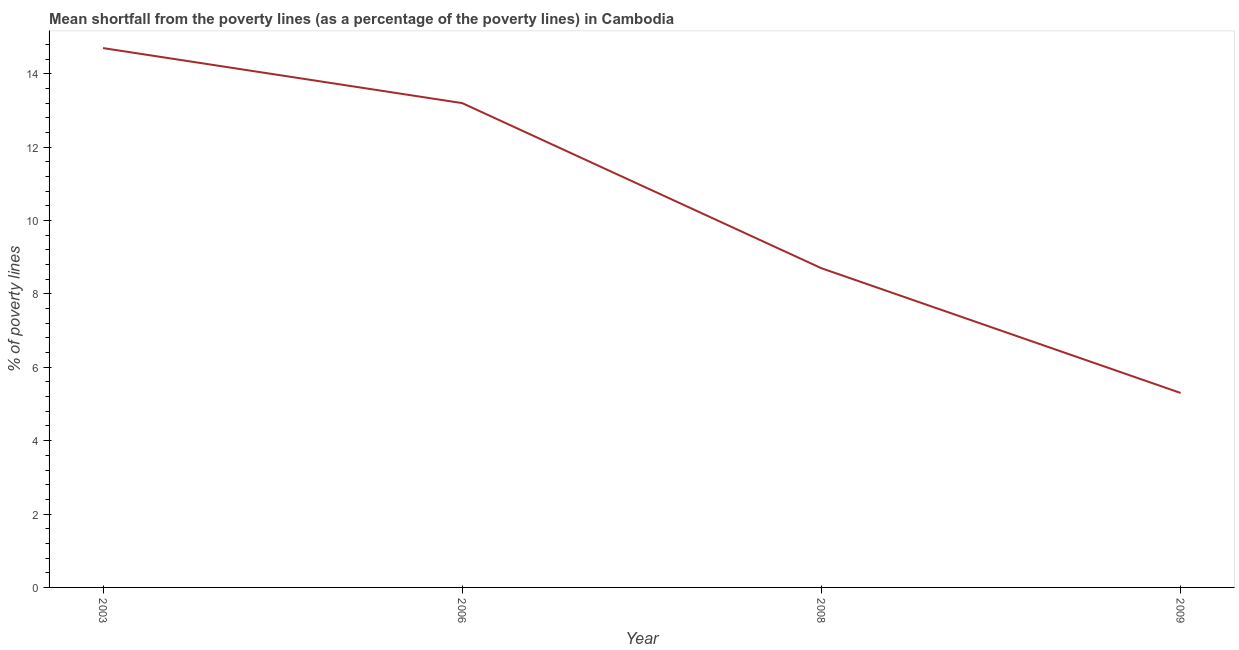Across all years, what is the maximum poverty gap at national poverty lines?
Offer a very short reply. 14.7. Across all years, what is the minimum poverty gap at national poverty lines?
Offer a terse response. 5.3. In which year was the poverty gap at national poverty lines maximum?
Make the answer very short. 2003. What is the sum of the poverty gap at national poverty lines?
Offer a terse response. 41.9. What is the average poverty gap at national poverty lines per year?
Offer a very short reply. 10.47. What is the median poverty gap at national poverty lines?
Keep it short and to the point. 10.95. In how many years, is the poverty gap at national poverty lines greater than 5.6 %?
Provide a short and direct response. 3. What is the ratio of the poverty gap at national poverty lines in 2006 to that in 2008?
Keep it short and to the point. 1.52. Is the poverty gap at national poverty lines in 2003 less than that in 2009?
Your answer should be very brief. No. Is the difference between the poverty gap at national poverty lines in 2006 and 2008 greater than the difference between any two years?
Your response must be concise. No. What is the difference between the highest and the second highest poverty gap at national poverty lines?
Your answer should be very brief. 1.5. What is the difference between the highest and the lowest poverty gap at national poverty lines?
Your answer should be compact. 9.4. In how many years, is the poverty gap at national poverty lines greater than the average poverty gap at national poverty lines taken over all years?
Offer a terse response. 2. Does the poverty gap at national poverty lines monotonically increase over the years?
Provide a succinct answer. No. What is the difference between two consecutive major ticks on the Y-axis?
Keep it short and to the point. 2. Are the values on the major ticks of Y-axis written in scientific E-notation?
Keep it short and to the point. No. Does the graph contain any zero values?
Offer a terse response. No. Does the graph contain grids?
Provide a short and direct response. No. What is the title of the graph?
Your answer should be very brief. Mean shortfall from the poverty lines (as a percentage of the poverty lines) in Cambodia. What is the label or title of the Y-axis?
Ensure brevity in your answer.  % of poverty lines. What is the % of poverty lines in 2003?
Offer a terse response. 14.7. What is the % of poverty lines of 2009?
Make the answer very short. 5.3. What is the difference between the % of poverty lines in 2003 and 2009?
Keep it short and to the point. 9.4. What is the difference between the % of poverty lines in 2006 and 2008?
Make the answer very short. 4.5. What is the difference between the % of poverty lines in 2008 and 2009?
Make the answer very short. 3.4. What is the ratio of the % of poverty lines in 2003 to that in 2006?
Your response must be concise. 1.11. What is the ratio of the % of poverty lines in 2003 to that in 2008?
Provide a short and direct response. 1.69. What is the ratio of the % of poverty lines in 2003 to that in 2009?
Give a very brief answer. 2.77. What is the ratio of the % of poverty lines in 2006 to that in 2008?
Offer a terse response. 1.52. What is the ratio of the % of poverty lines in 2006 to that in 2009?
Offer a very short reply. 2.49. What is the ratio of the % of poverty lines in 2008 to that in 2009?
Offer a very short reply. 1.64. 